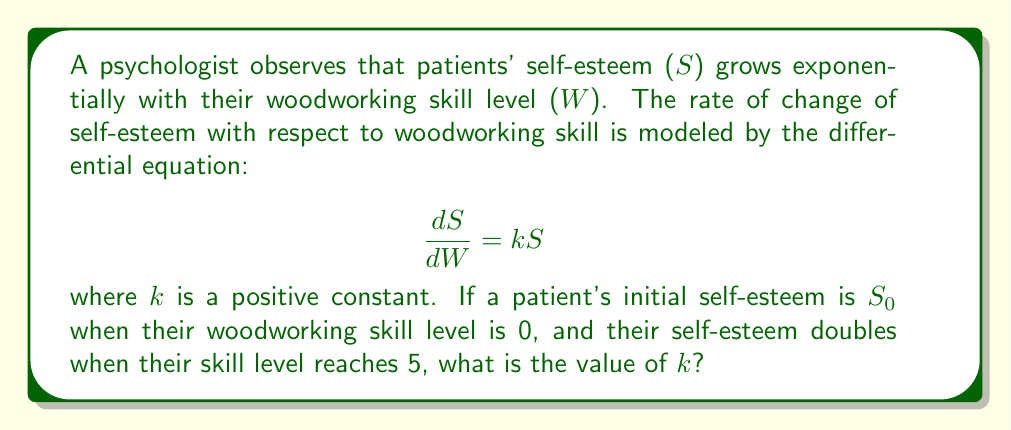Help me with this question. 1) The given differential equation is separable. We can solve it as follows:

   $$\frac{dS}{S} = k dW$$

2) Integrating both sides:

   $$\int \frac{dS}{S} = \int k dW$$
   $$\ln|S| = kW + C$$

3) Solving for S:

   $$S = Ae^{kW}$$

   where A is a constant of integration.

4) Using the initial condition: when W = 0, S = $S_0$
   
   $$S_0 = Ae^{k(0)} = A$$

5) Therefore, our solution is:

   $$S = S_0e^{kW}$$

6) We're told that S doubles when W = 5. This means:

   $$2S_0 = S_0e^{k(5)}$$

7) Dividing both sides by $S_0$:

   $$2 = e^{5k}$$

8) Taking the natural log of both sides:

   $$\ln(2) = 5k$$

9) Solving for k:

   $$k = \frac{\ln(2)}{5}$$
Answer: $\frac{\ln(2)}{5}$ 